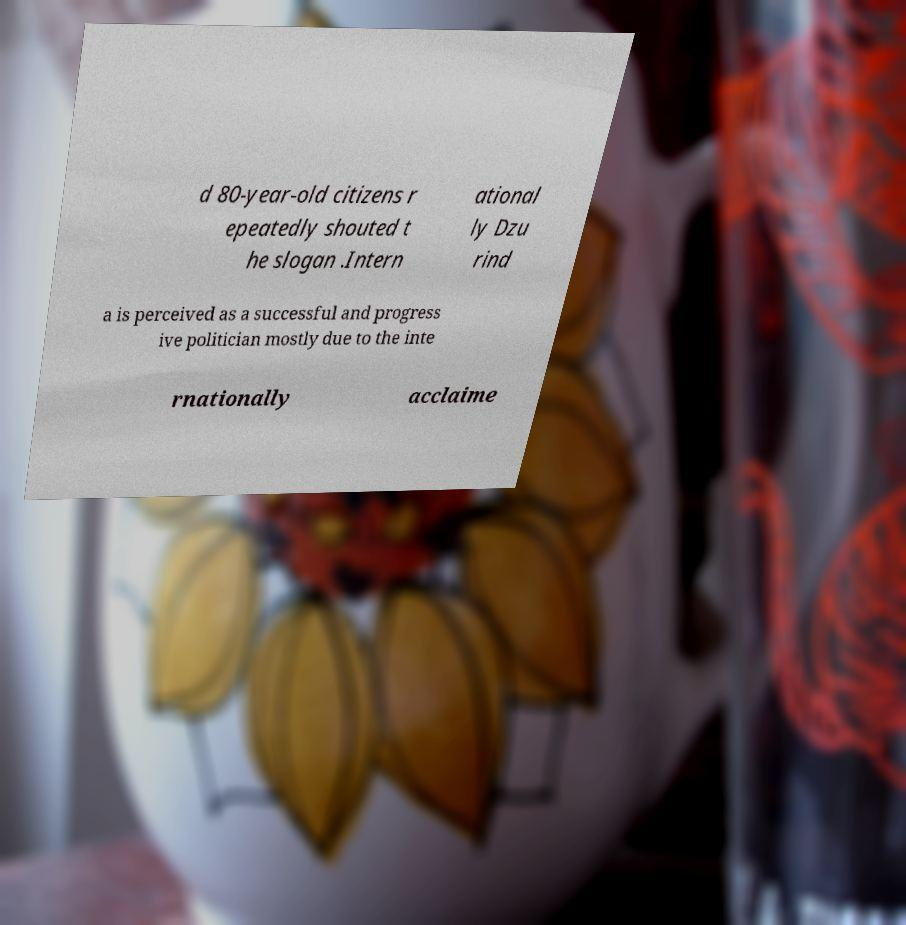What messages or text are displayed in this image? I need them in a readable, typed format. d 80-year-old citizens r epeatedly shouted t he slogan .Intern ational ly Dzu rind a is perceived as a successful and progress ive politician mostly due to the inte rnationally acclaime 